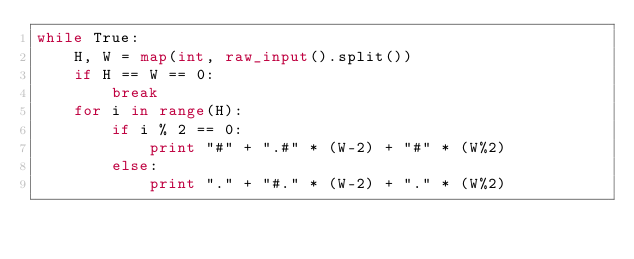Convert code to text. <code><loc_0><loc_0><loc_500><loc_500><_Python_>while True:
    H, W = map(int, raw_input().split())
    if H == W == 0:
        break
    for i in range(H):
        if i % 2 == 0:
            print "#" + ".#" * (W-2) + "#" * (W%2)
        else:
            print "." + "#." * (W-2) + "." * (W%2)
</code> 